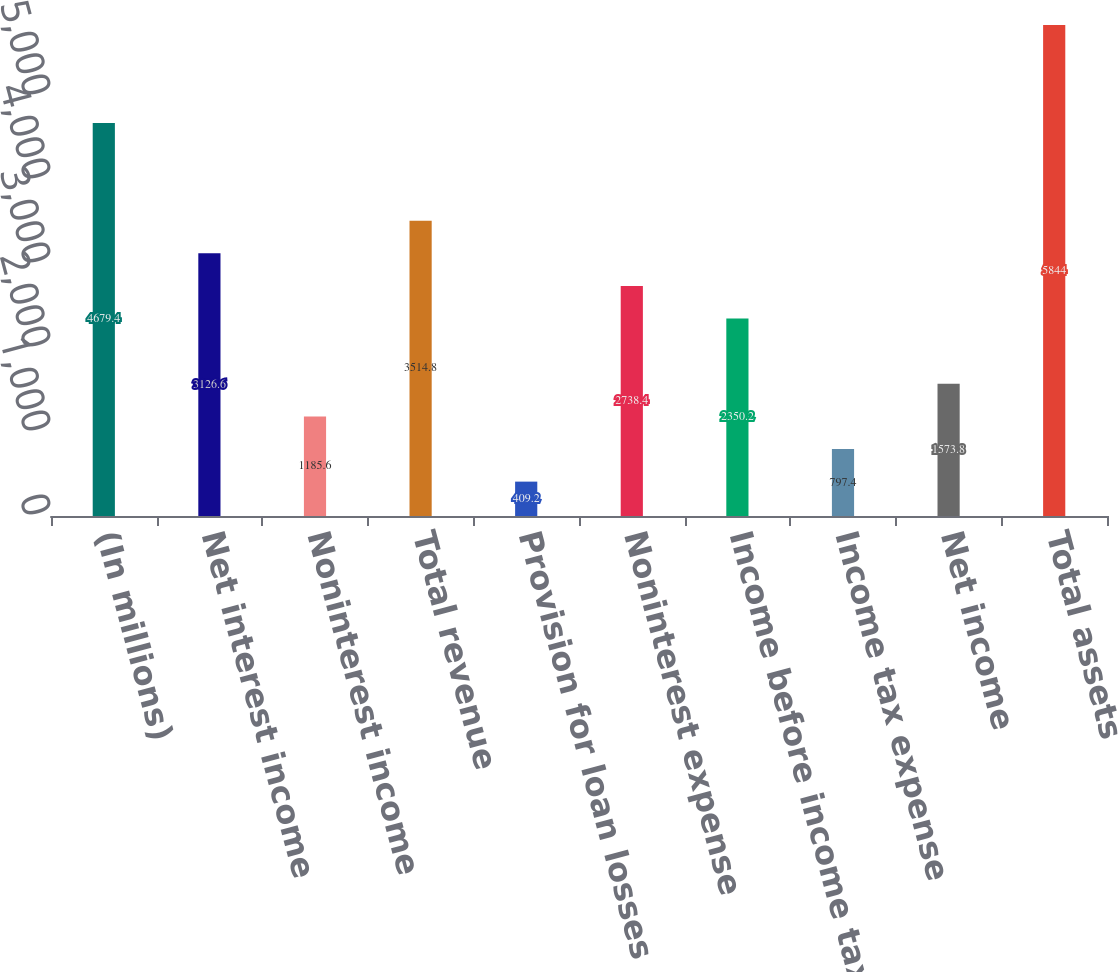Convert chart. <chart><loc_0><loc_0><loc_500><loc_500><bar_chart><fcel>(In millions)<fcel>Net interest income<fcel>Noninterest income<fcel>Total revenue<fcel>Provision for loan losses<fcel>Noninterest expense<fcel>Income before income taxes<fcel>Income tax expense<fcel>Net income<fcel>Total assets<nl><fcel>4679.4<fcel>3126.6<fcel>1185.6<fcel>3514.8<fcel>409.2<fcel>2738.4<fcel>2350.2<fcel>797.4<fcel>1573.8<fcel>5844<nl></chart> 